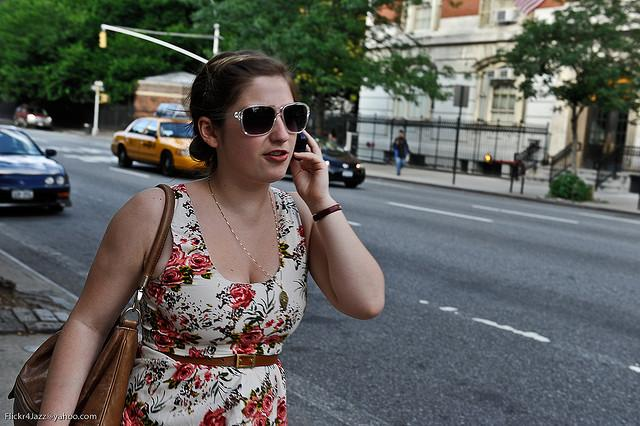What is the woman wearing sunglasses doing? Please explain your reasoning. talking. She is talking on a phone. 